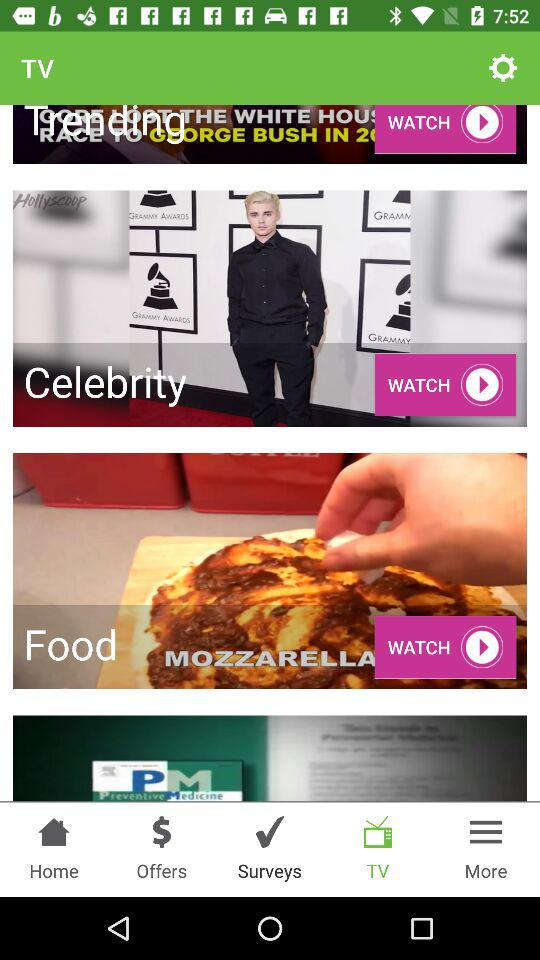Which option is selected? The selected option is "TV". 